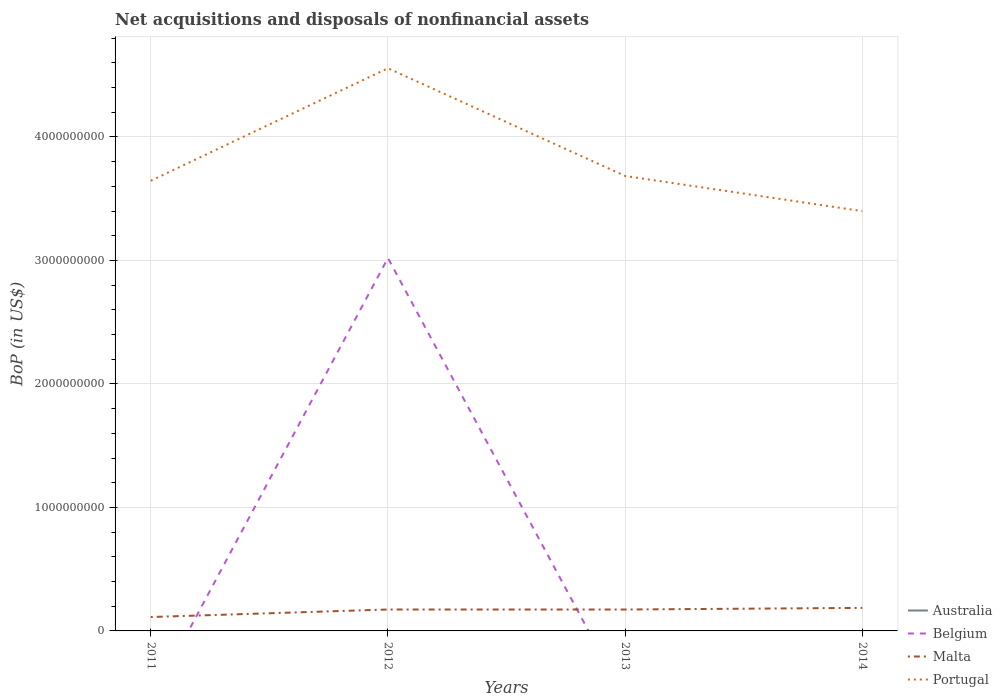How many different coloured lines are there?
Make the answer very short. 3. Is the number of lines equal to the number of legend labels?
Your answer should be very brief. No. Across all years, what is the maximum Balance of Payments in Portugal?
Offer a terse response. 3.40e+09. What is the total Balance of Payments in Portugal in the graph?
Ensure brevity in your answer.  -9.11e+08. What is the difference between the highest and the second highest Balance of Payments in Portugal?
Your response must be concise. 1.16e+09. What is the difference between the highest and the lowest Balance of Payments in Belgium?
Ensure brevity in your answer.  1. How many years are there in the graph?
Your answer should be very brief. 4. What is the difference between two consecutive major ticks on the Y-axis?
Your response must be concise. 1.00e+09. Are the values on the major ticks of Y-axis written in scientific E-notation?
Provide a succinct answer. No. Does the graph contain any zero values?
Give a very brief answer. Yes. Does the graph contain grids?
Keep it short and to the point. Yes. Where does the legend appear in the graph?
Your answer should be compact. Bottom right. What is the title of the graph?
Keep it short and to the point. Net acquisitions and disposals of nonfinancial assets. What is the label or title of the X-axis?
Your response must be concise. Years. What is the label or title of the Y-axis?
Ensure brevity in your answer.  BoP (in US$). What is the BoP (in US$) of Malta in 2011?
Ensure brevity in your answer.  1.13e+08. What is the BoP (in US$) of Portugal in 2011?
Offer a terse response. 3.64e+09. What is the BoP (in US$) of Australia in 2012?
Offer a terse response. 0. What is the BoP (in US$) of Belgium in 2012?
Keep it short and to the point. 3.02e+09. What is the BoP (in US$) of Malta in 2012?
Offer a very short reply. 1.73e+08. What is the BoP (in US$) of Portugal in 2012?
Provide a succinct answer. 4.56e+09. What is the BoP (in US$) of Australia in 2013?
Keep it short and to the point. 0. What is the BoP (in US$) of Malta in 2013?
Keep it short and to the point. 1.73e+08. What is the BoP (in US$) of Portugal in 2013?
Offer a very short reply. 3.68e+09. What is the BoP (in US$) of Australia in 2014?
Offer a very short reply. 0. What is the BoP (in US$) in Belgium in 2014?
Provide a succinct answer. 0. What is the BoP (in US$) of Malta in 2014?
Your response must be concise. 1.86e+08. What is the BoP (in US$) of Portugal in 2014?
Provide a succinct answer. 3.40e+09. Across all years, what is the maximum BoP (in US$) of Belgium?
Provide a short and direct response. 3.02e+09. Across all years, what is the maximum BoP (in US$) in Malta?
Offer a terse response. 1.86e+08. Across all years, what is the maximum BoP (in US$) of Portugal?
Keep it short and to the point. 4.56e+09. Across all years, what is the minimum BoP (in US$) in Belgium?
Provide a short and direct response. 0. Across all years, what is the minimum BoP (in US$) of Malta?
Give a very brief answer. 1.13e+08. Across all years, what is the minimum BoP (in US$) of Portugal?
Your response must be concise. 3.40e+09. What is the total BoP (in US$) of Australia in the graph?
Provide a succinct answer. 0. What is the total BoP (in US$) in Belgium in the graph?
Keep it short and to the point. 3.02e+09. What is the total BoP (in US$) in Malta in the graph?
Give a very brief answer. 6.46e+08. What is the total BoP (in US$) in Portugal in the graph?
Give a very brief answer. 1.53e+1. What is the difference between the BoP (in US$) in Malta in 2011 and that in 2012?
Ensure brevity in your answer.  -6.08e+07. What is the difference between the BoP (in US$) in Portugal in 2011 and that in 2012?
Provide a short and direct response. -9.11e+08. What is the difference between the BoP (in US$) of Malta in 2011 and that in 2013?
Your response must be concise. -6.07e+07. What is the difference between the BoP (in US$) of Portugal in 2011 and that in 2013?
Offer a terse response. -3.87e+07. What is the difference between the BoP (in US$) of Malta in 2011 and that in 2014?
Make the answer very short. -7.39e+07. What is the difference between the BoP (in US$) of Portugal in 2011 and that in 2014?
Offer a terse response. 2.46e+08. What is the difference between the BoP (in US$) in Malta in 2012 and that in 2013?
Your answer should be compact. 1.08e+05. What is the difference between the BoP (in US$) in Portugal in 2012 and that in 2013?
Offer a terse response. 8.72e+08. What is the difference between the BoP (in US$) of Malta in 2012 and that in 2014?
Keep it short and to the point. -1.31e+07. What is the difference between the BoP (in US$) in Portugal in 2012 and that in 2014?
Your answer should be very brief. 1.16e+09. What is the difference between the BoP (in US$) of Malta in 2013 and that in 2014?
Keep it short and to the point. -1.32e+07. What is the difference between the BoP (in US$) of Portugal in 2013 and that in 2014?
Give a very brief answer. 2.85e+08. What is the difference between the BoP (in US$) of Malta in 2011 and the BoP (in US$) of Portugal in 2012?
Keep it short and to the point. -4.44e+09. What is the difference between the BoP (in US$) of Malta in 2011 and the BoP (in US$) of Portugal in 2013?
Provide a succinct answer. -3.57e+09. What is the difference between the BoP (in US$) in Malta in 2011 and the BoP (in US$) in Portugal in 2014?
Make the answer very short. -3.29e+09. What is the difference between the BoP (in US$) of Belgium in 2012 and the BoP (in US$) of Malta in 2013?
Provide a succinct answer. 2.85e+09. What is the difference between the BoP (in US$) of Belgium in 2012 and the BoP (in US$) of Portugal in 2013?
Offer a very short reply. -6.65e+08. What is the difference between the BoP (in US$) in Malta in 2012 and the BoP (in US$) in Portugal in 2013?
Your response must be concise. -3.51e+09. What is the difference between the BoP (in US$) in Belgium in 2012 and the BoP (in US$) in Malta in 2014?
Keep it short and to the point. 2.83e+09. What is the difference between the BoP (in US$) in Belgium in 2012 and the BoP (in US$) in Portugal in 2014?
Provide a succinct answer. -3.80e+08. What is the difference between the BoP (in US$) in Malta in 2012 and the BoP (in US$) in Portugal in 2014?
Your answer should be very brief. -3.23e+09. What is the difference between the BoP (in US$) in Malta in 2013 and the BoP (in US$) in Portugal in 2014?
Keep it short and to the point. -3.23e+09. What is the average BoP (in US$) in Belgium per year?
Offer a very short reply. 7.55e+08. What is the average BoP (in US$) in Malta per year?
Offer a terse response. 1.61e+08. What is the average BoP (in US$) of Portugal per year?
Your response must be concise. 3.82e+09. In the year 2011, what is the difference between the BoP (in US$) of Malta and BoP (in US$) of Portugal?
Provide a succinct answer. -3.53e+09. In the year 2012, what is the difference between the BoP (in US$) of Belgium and BoP (in US$) of Malta?
Your response must be concise. 2.85e+09. In the year 2012, what is the difference between the BoP (in US$) in Belgium and BoP (in US$) in Portugal?
Your answer should be very brief. -1.54e+09. In the year 2012, what is the difference between the BoP (in US$) of Malta and BoP (in US$) of Portugal?
Ensure brevity in your answer.  -4.38e+09. In the year 2013, what is the difference between the BoP (in US$) in Malta and BoP (in US$) in Portugal?
Offer a very short reply. -3.51e+09. In the year 2014, what is the difference between the BoP (in US$) in Malta and BoP (in US$) in Portugal?
Your response must be concise. -3.21e+09. What is the ratio of the BoP (in US$) in Malta in 2011 to that in 2012?
Offer a very short reply. 0.65. What is the ratio of the BoP (in US$) of Portugal in 2011 to that in 2012?
Offer a very short reply. 0.8. What is the ratio of the BoP (in US$) of Malta in 2011 to that in 2013?
Give a very brief answer. 0.65. What is the ratio of the BoP (in US$) of Portugal in 2011 to that in 2013?
Your answer should be compact. 0.99. What is the ratio of the BoP (in US$) in Malta in 2011 to that in 2014?
Your answer should be compact. 0.6. What is the ratio of the BoP (in US$) in Portugal in 2011 to that in 2014?
Provide a short and direct response. 1.07. What is the ratio of the BoP (in US$) of Malta in 2012 to that in 2013?
Make the answer very short. 1. What is the ratio of the BoP (in US$) in Portugal in 2012 to that in 2013?
Your response must be concise. 1.24. What is the ratio of the BoP (in US$) of Malta in 2012 to that in 2014?
Keep it short and to the point. 0.93. What is the ratio of the BoP (in US$) in Portugal in 2012 to that in 2014?
Your answer should be compact. 1.34. What is the ratio of the BoP (in US$) of Malta in 2013 to that in 2014?
Your answer should be very brief. 0.93. What is the ratio of the BoP (in US$) in Portugal in 2013 to that in 2014?
Your response must be concise. 1.08. What is the difference between the highest and the second highest BoP (in US$) in Malta?
Your answer should be compact. 1.31e+07. What is the difference between the highest and the second highest BoP (in US$) in Portugal?
Provide a short and direct response. 8.72e+08. What is the difference between the highest and the lowest BoP (in US$) of Belgium?
Ensure brevity in your answer.  3.02e+09. What is the difference between the highest and the lowest BoP (in US$) of Malta?
Provide a succinct answer. 7.39e+07. What is the difference between the highest and the lowest BoP (in US$) in Portugal?
Make the answer very short. 1.16e+09. 